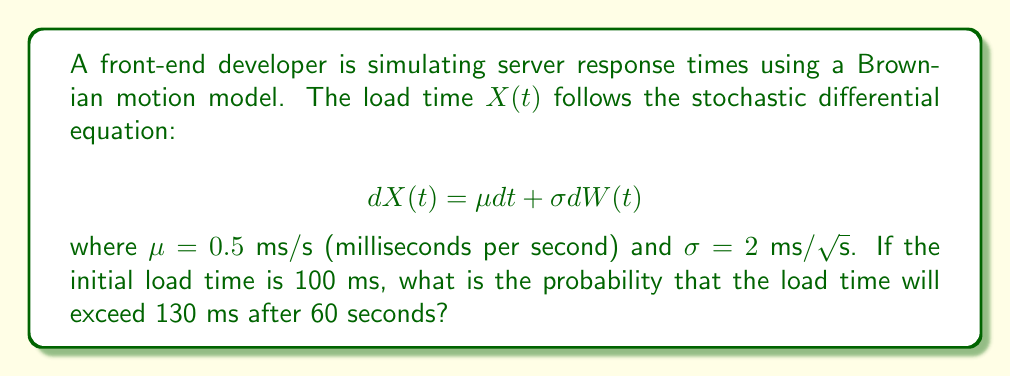Provide a solution to this math problem. To solve this problem, we'll follow these steps:

1) In a Brownian motion model, the change in $X(t)$ over a time interval $t$ is normally distributed with mean $\mu t$ and variance $\sigma^2 t$.

2) After time $t$, $X(t)$ is normally distributed with:
   Mean: $E[X(t)] = X(0) + \mu t$
   Variance: $Var[X(t)] = \sigma^2 t$

3) For our problem:
   $X(0) = 100$ ms
   $t = 60$ s
   $\mu = 0.5$ ms/s
   $\sigma = 2$ ms/√s

4) Calculate the mean after 60 seconds:
   $E[X(60)] = 100 + 0.5 * 60 = 130$ ms

5) Calculate the variance after 60 seconds:
   $Var[X(60)] = 2^2 * 60 = 240$ ms²

6) Calculate the standard deviation:
   $SD[X(60)] = \sqrt{240} \approx 15.49$ ms

7) We want to find $P(X(60) > 130)$. We can standardize this:
   $Z = \frac{X(60) - E[X(60)]}{SD[X(60)]} = \frac{130 - 130}{15.49} = 0$

8) The probability we're looking for is:
   $P(Z > 0) = 1 - \Phi(0) = 0.5$

Where $\Phi$ is the cumulative distribution function of the standard normal distribution.
Answer: 0.5 